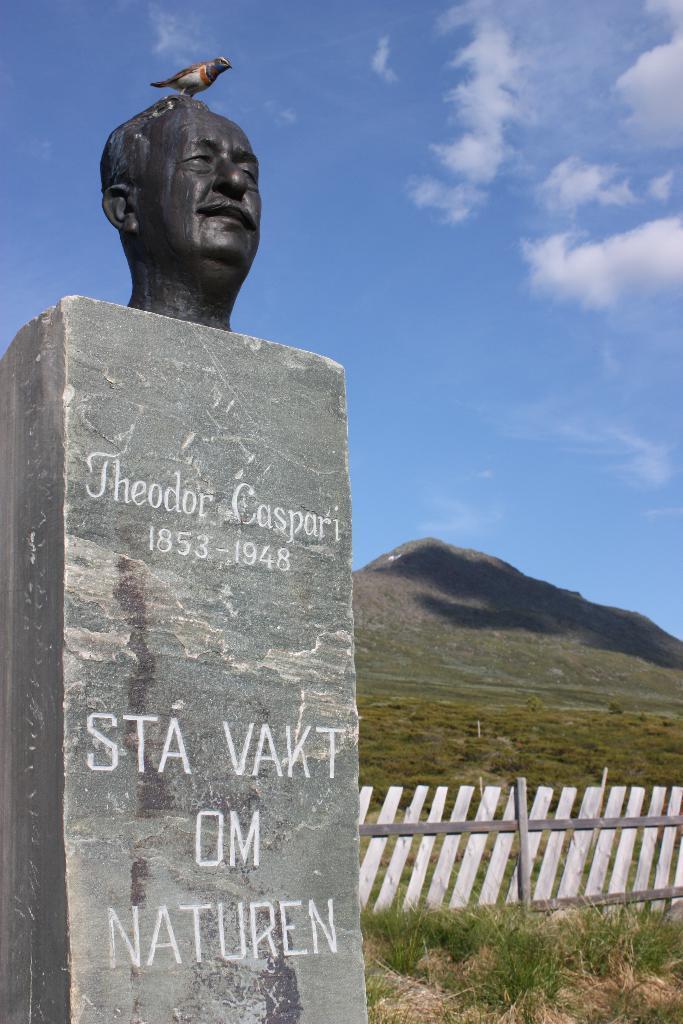Describe this image in one or two sentences. In this picture I can see words and numbers on the pillar, there is a bird standing on the statue of a person head, there is fence, grass, hills, and in the background there is sky. 